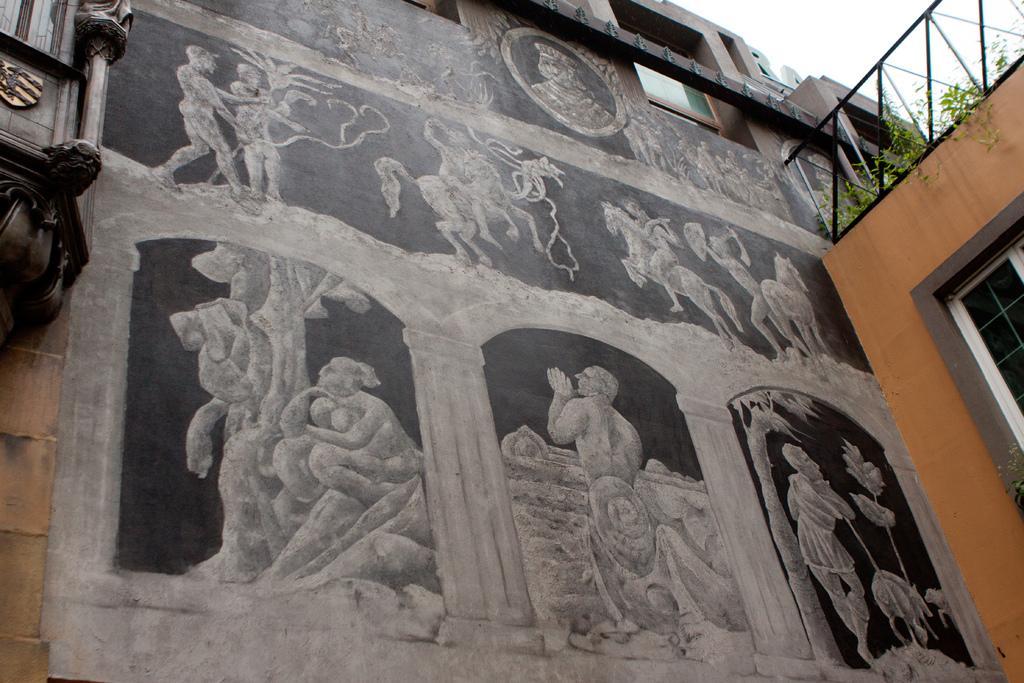Please provide a concise description of this image. In this image I can see there are paintings of statues on this wall. On the right side there are plants on the building and there is a glass window, at the top it is the sky. 